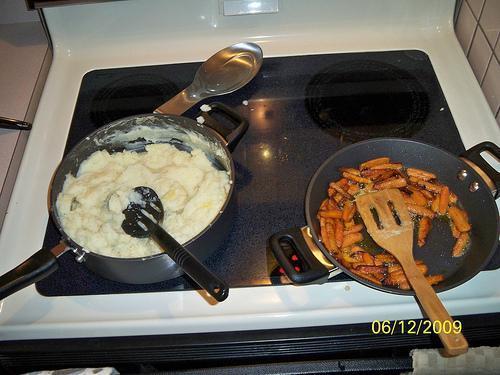How many pots are there?
Give a very brief answer. 2. 